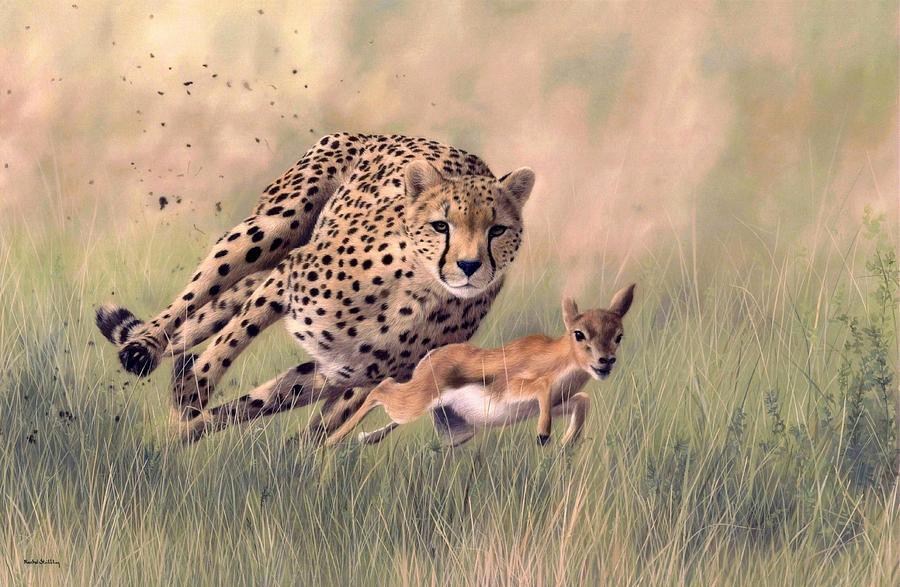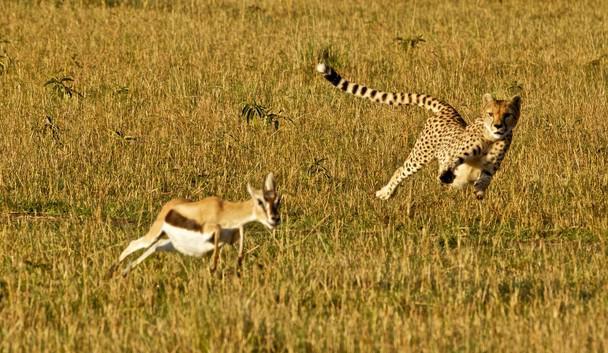The first image is the image on the left, the second image is the image on the right. Assess this claim about the two images: "All cheetahs appear to be actively chasing adult gazelles.". Correct or not? Answer yes or no. No. The first image is the image on the left, the second image is the image on the right. Given the left and right images, does the statement "A single cheetah is chasing after a single prey in each image." hold true? Answer yes or no. Yes. 